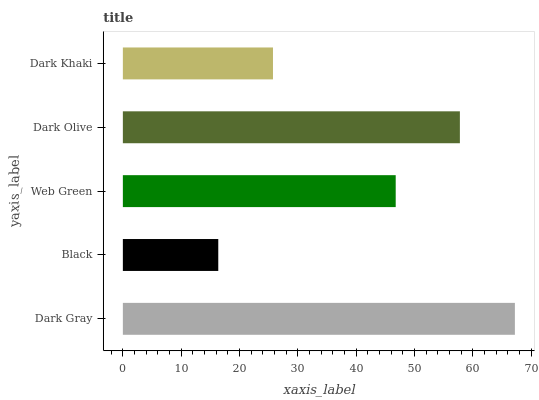Is Black the minimum?
Answer yes or no. Yes. Is Dark Gray the maximum?
Answer yes or no. Yes. Is Web Green the minimum?
Answer yes or no. No. Is Web Green the maximum?
Answer yes or no. No. Is Web Green greater than Black?
Answer yes or no. Yes. Is Black less than Web Green?
Answer yes or no. Yes. Is Black greater than Web Green?
Answer yes or no. No. Is Web Green less than Black?
Answer yes or no. No. Is Web Green the high median?
Answer yes or no. Yes. Is Web Green the low median?
Answer yes or no. Yes. Is Dark Khaki the high median?
Answer yes or no. No. Is Dark Gray the low median?
Answer yes or no. No. 